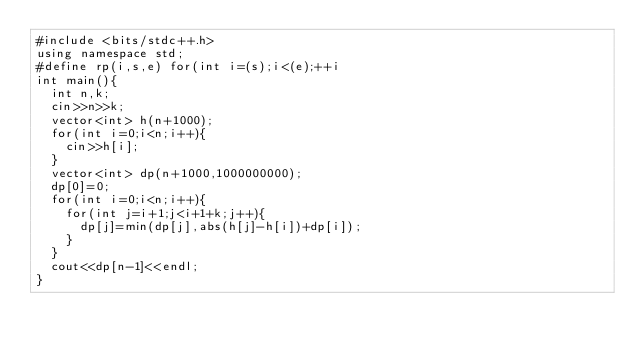<code> <loc_0><loc_0><loc_500><loc_500><_C++_>#include <bits/stdc++.h>
using namespace std;
#define rp(i,s,e) for(int i=(s);i<(e);++i
int main(){
  int n,k;
  cin>>n>>k;
  vector<int> h(n+1000);
  for(int i=0;i<n;i++){
    cin>>h[i];
  }
  vector<int> dp(n+1000,1000000000);
  dp[0]=0;
  for(int i=0;i<n;i++){
    for(int j=i+1;j<i+1+k;j++){
      dp[j]=min(dp[j],abs(h[j]-h[i])+dp[i]);
    }
  }
  cout<<dp[n-1]<<endl;
}</code> 